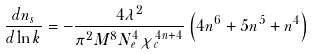Convert formula to latex. <formula><loc_0><loc_0><loc_500><loc_500>\frac { d n _ { s } } { d \ln k } = - \frac { 4 \lambda ^ { 2 } } { \pi ^ { 2 } M ^ { 8 } N _ { e } ^ { 4 } \chi _ { c } ^ { 4 n + 4 } } \left ( 4 n ^ { 6 } + 5 n ^ { 5 } + n ^ { 4 } \right )</formula> 